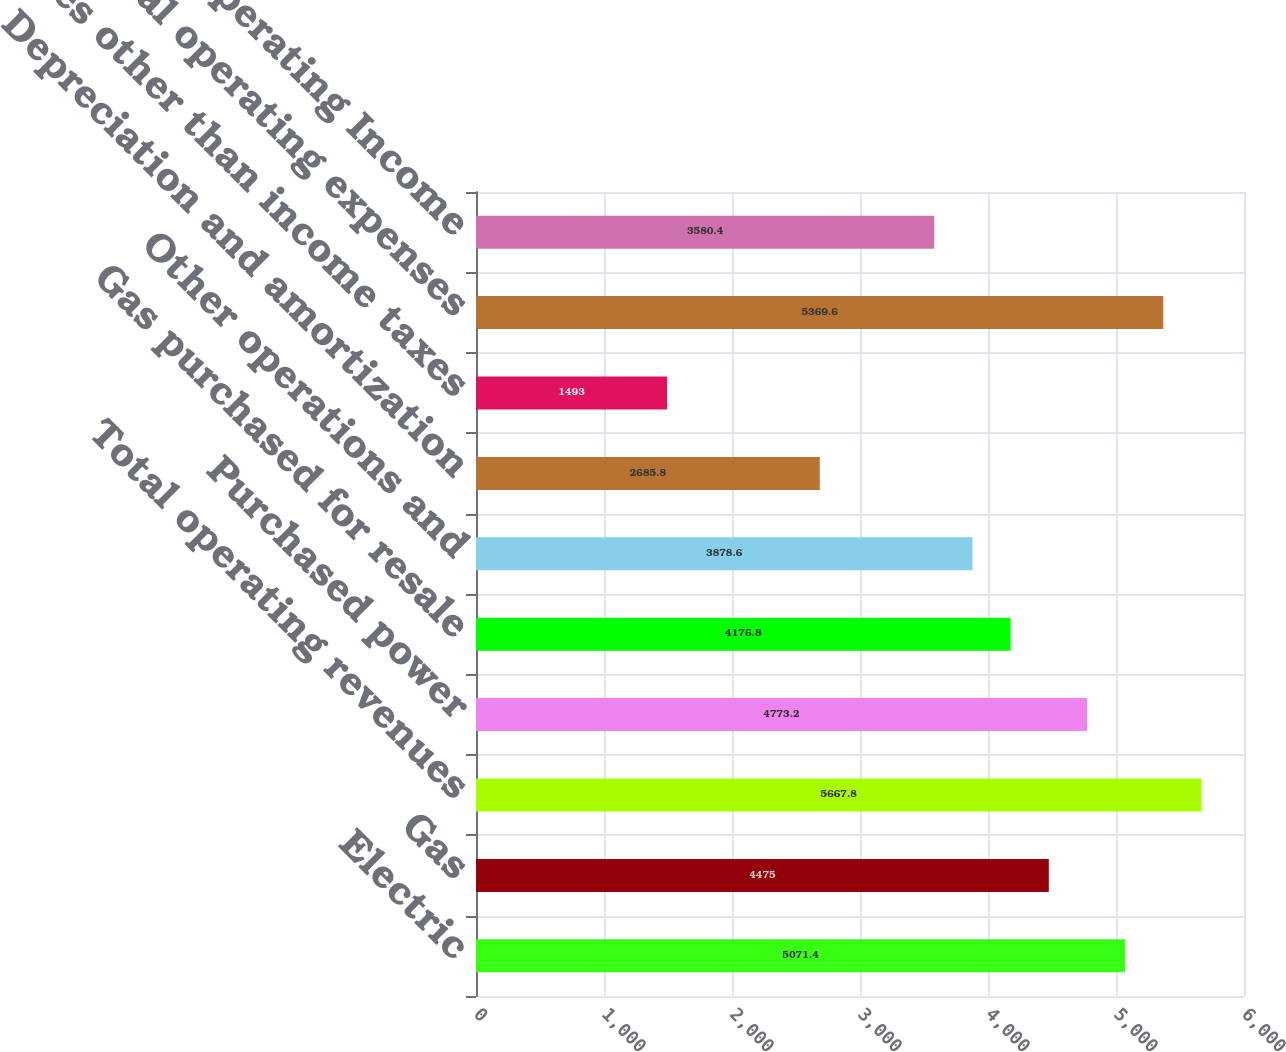<chart> <loc_0><loc_0><loc_500><loc_500><bar_chart><fcel>Electric<fcel>Gas<fcel>Total operating revenues<fcel>Purchased power<fcel>Gas purchased for resale<fcel>Other operations and<fcel>Depreciation and amortization<fcel>Taxes other than income taxes<fcel>Total operating expenses<fcel>Operating Income<nl><fcel>5071.4<fcel>4475<fcel>5667.8<fcel>4773.2<fcel>4176.8<fcel>3878.6<fcel>2685.8<fcel>1493<fcel>5369.6<fcel>3580.4<nl></chart> 